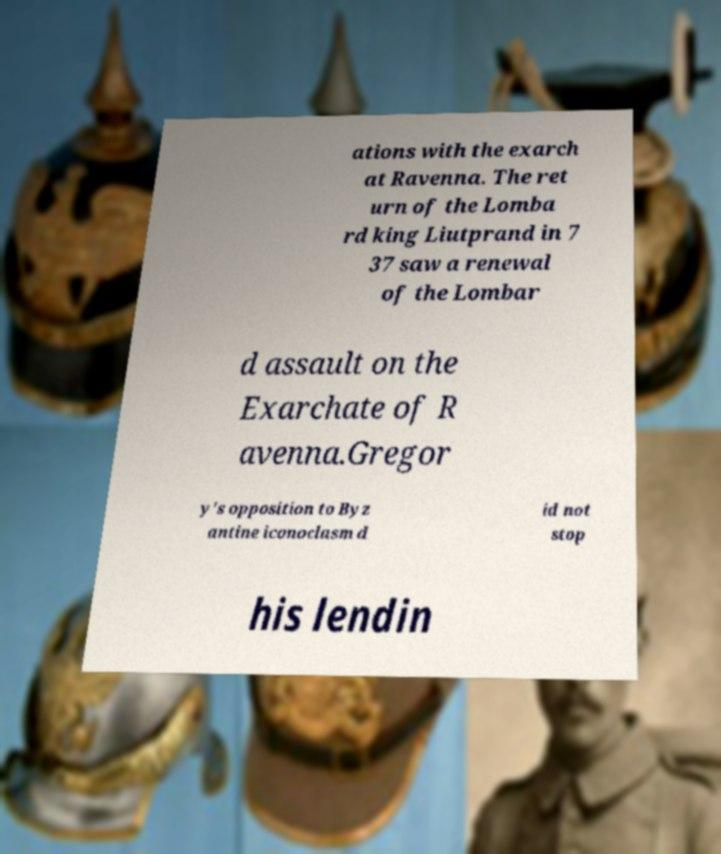Can you read and provide the text displayed in the image?This photo seems to have some interesting text. Can you extract and type it out for me? ations with the exarch at Ravenna. The ret urn of the Lomba rd king Liutprand in 7 37 saw a renewal of the Lombar d assault on the Exarchate of R avenna.Gregor y's opposition to Byz antine iconoclasm d id not stop his lendin 